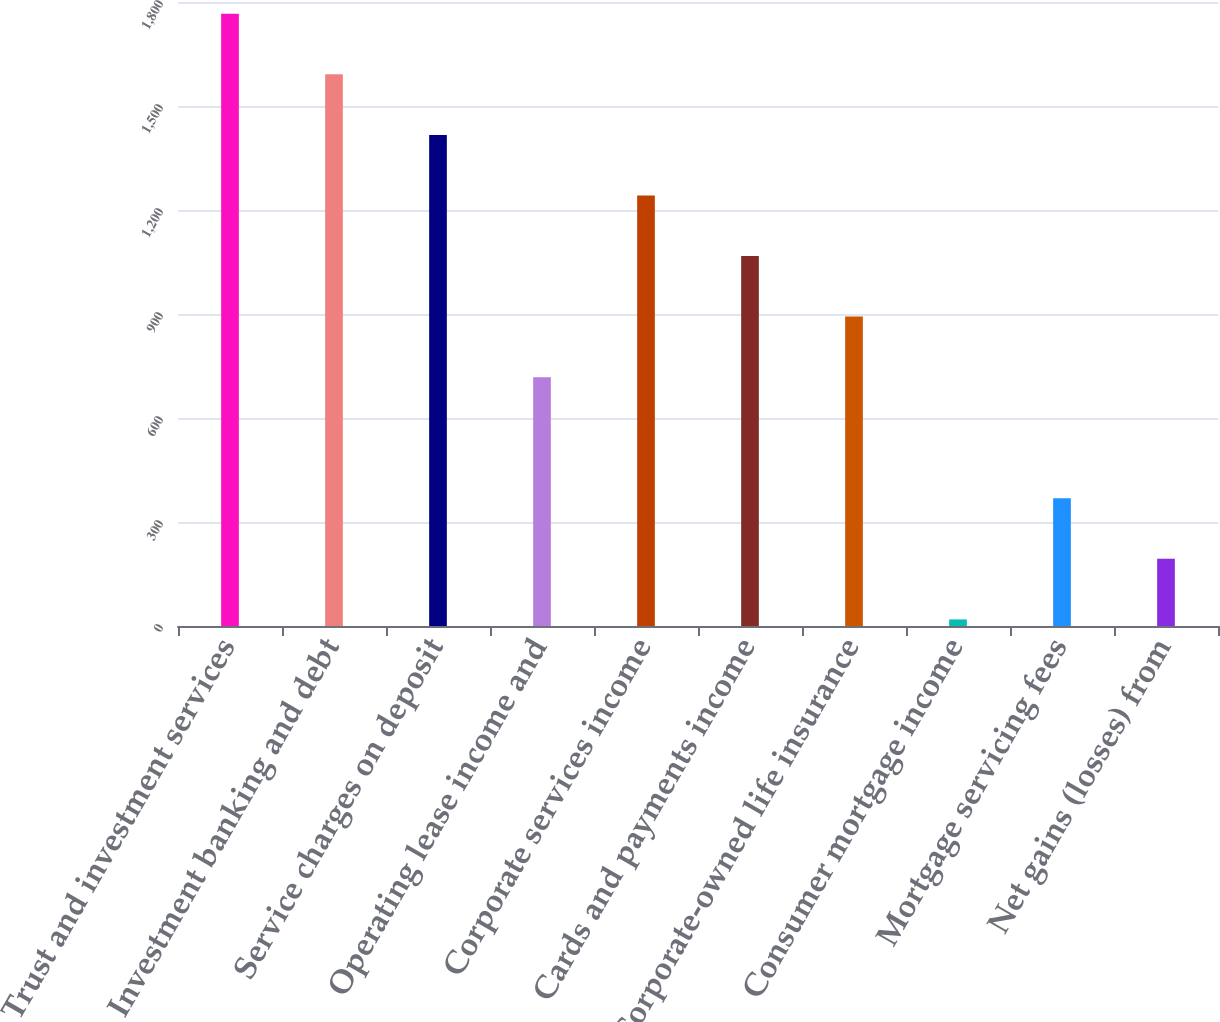Convert chart. <chart><loc_0><loc_0><loc_500><loc_500><bar_chart><fcel>Trust and investment services<fcel>Investment banking and debt<fcel>Service charges on deposit<fcel>Operating lease income and<fcel>Corporate services income<fcel>Cards and payments income<fcel>Corporate-owned life insurance<fcel>Consumer mortgage income<fcel>Mortgage servicing fees<fcel>Net gains (losses) from<nl><fcel>1766<fcel>1591.3<fcel>1416.6<fcel>717.8<fcel>1241.9<fcel>1067.2<fcel>892.5<fcel>19<fcel>368.4<fcel>193.7<nl></chart> 